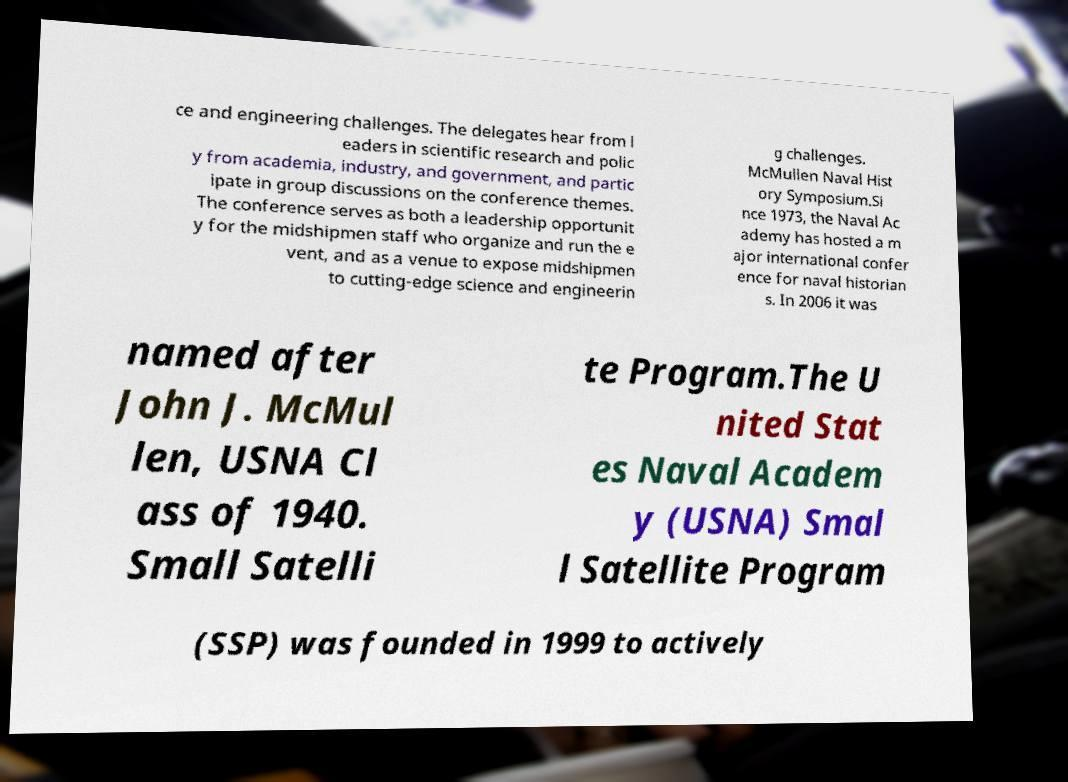For documentation purposes, I need the text within this image transcribed. Could you provide that? ce and engineering challenges. The delegates hear from l eaders in scientific research and polic y from academia, industry, and government, and partic ipate in group discussions on the conference themes. The conference serves as both a leadership opportunit y for the midshipmen staff who organize and run the e vent, and as a venue to expose midshipmen to cutting-edge science and engineerin g challenges. McMullen Naval Hist ory Symposium.Si nce 1973, the Naval Ac ademy has hosted a m ajor international confer ence for naval historian s. In 2006 it was named after John J. McMul len, USNA Cl ass of 1940. Small Satelli te Program.The U nited Stat es Naval Academ y (USNA) Smal l Satellite Program (SSP) was founded in 1999 to actively 